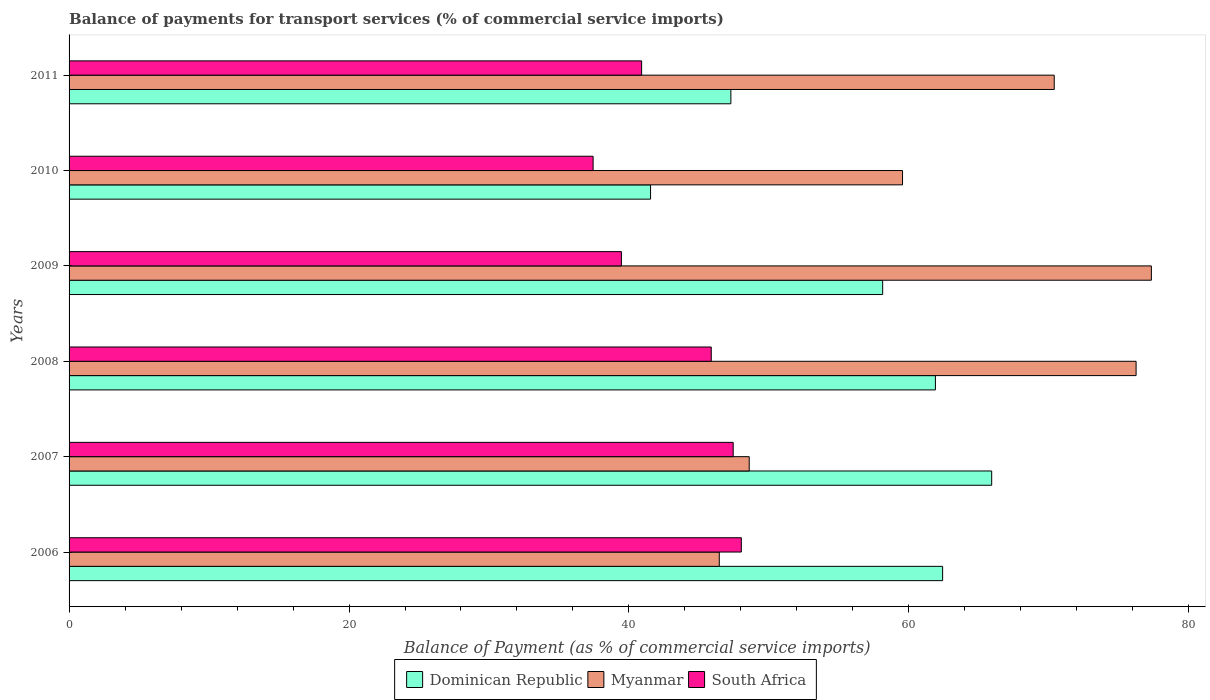How many different coloured bars are there?
Your answer should be compact. 3. How many groups of bars are there?
Provide a succinct answer. 6. Are the number of bars per tick equal to the number of legend labels?
Make the answer very short. Yes. Are the number of bars on each tick of the Y-axis equal?
Give a very brief answer. Yes. How many bars are there on the 2nd tick from the top?
Ensure brevity in your answer.  3. How many bars are there on the 6th tick from the bottom?
Give a very brief answer. 3. What is the label of the 3rd group of bars from the top?
Your answer should be compact. 2009. In how many cases, is the number of bars for a given year not equal to the number of legend labels?
Your answer should be compact. 0. What is the balance of payments for transport services in South Africa in 2008?
Provide a short and direct response. 45.88. Across all years, what is the maximum balance of payments for transport services in Dominican Republic?
Your answer should be very brief. 65.92. Across all years, what is the minimum balance of payments for transport services in Myanmar?
Offer a terse response. 46.45. In which year was the balance of payments for transport services in Myanmar maximum?
Offer a terse response. 2009. What is the total balance of payments for transport services in South Africa in the graph?
Give a very brief answer. 259.16. What is the difference between the balance of payments for transport services in Dominican Republic in 2008 and that in 2009?
Keep it short and to the point. 3.77. What is the difference between the balance of payments for transport services in Dominican Republic in 2011 and the balance of payments for transport services in South Africa in 2008?
Your answer should be very brief. 1.4. What is the average balance of payments for transport services in Myanmar per year?
Your answer should be compact. 63.09. In the year 2007, what is the difference between the balance of payments for transport services in Dominican Republic and balance of payments for transport services in Myanmar?
Ensure brevity in your answer.  17.32. What is the ratio of the balance of payments for transport services in South Africa in 2006 to that in 2011?
Your answer should be very brief. 1.17. Is the balance of payments for transport services in Myanmar in 2006 less than that in 2011?
Your answer should be very brief. Yes. What is the difference between the highest and the second highest balance of payments for transport services in Dominican Republic?
Provide a short and direct response. 3.5. What is the difference between the highest and the lowest balance of payments for transport services in Dominican Republic?
Offer a terse response. 24.37. In how many years, is the balance of payments for transport services in Dominican Republic greater than the average balance of payments for transport services in Dominican Republic taken over all years?
Your answer should be compact. 4. What does the 3rd bar from the top in 2006 represents?
Your answer should be compact. Dominican Republic. What does the 2nd bar from the bottom in 2009 represents?
Offer a terse response. Myanmar. Are all the bars in the graph horizontal?
Provide a succinct answer. Yes. How many years are there in the graph?
Offer a very short reply. 6. What is the difference between two consecutive major ticks on the X-axis?
Provide a succinct answer. 20. Are the values on the major ticks of X-axis written in scientific E-notation?
Your answer should be compact. No. Does the graph contain grids?
Keep it short and to the point. No. Where does the legend appear in the graph?
Your response must be concise. Bottom center. How are the legend labels stacked?
Provide a succinct answer. Horizontal. What is the title of the graph?
Give a very brief answer. Balance of payments for transport services (% of commercial service imports). Does "Canada" appear as one of the legend labels in the graph?
Give a very brief answer. No. What is the label or title of the X-axis?
Provide a short and direct response. Balance of Payment (as % of commercial service imports). What is the Balance of Payment (as % of commercial service imports) of Dominican Republic in 2006?
Offer a terse response. 62.41. What is the Balance of Payment (as % of commercial service imports) in Myanmar in 2006?
Your answer should be very brief. 46.45. What is the Balance of Payment (as % of commercial service imports) of South Africa in 2006?
Make the answer very short. 48.03. What is the Balance of Payment (as % of commercial service imports) of Dominican Republic in 2007?
Provide a short and direct response. 65.92. What is the Balance of Payment (as % of commercial service imports) of Myanmar in 2007?
Make the answer very short. 48.59. What is the Balance of Payment (as % of commercial service imports) of South Africa in 2007?
Ensure brevity in your answer.  47.45. What is the Balance of Payment (as % of commercial service imports) of Dominican Republic in 2008?
Offer a very short reply. 61.9. What is the Balance of Payment (as % of commercial service imports) in Myanmar in 2008?
Ensure brevity in your answer.  76.23. What is the Balance of Payment (as % of commercial service imports) in South Africa in 2008?
Provide a short and direct response. 45.88. What is the Balance of Payment (as % of commercial service imports) in Dominican Republic in 2009?
Make the answer very short. 58.13. What is the Balance of Payment (as % of commercial service imports) in Myanmar in 2009?
Give a very brief answer. 77.32. What is the Balance of Payment (as % of commercial service imports) in South Africa in 2009?
Ensure brevity in your answer.  39.46. What is the Balance of Payment (as % of commercial service imports) in Dominican Republic in 2010?
Ensure brevity in your answer.  41.54. What is the Balance of Payment (as % of commercial service imports) of Myanmar in 2010?
Ensure brevity in your answer.  59.55. What is the Balance of Payment (as % of commercial service imports) in South Africa in 2010?
Give a very brief answer. 37.44. What is the Balance of Payment (as % of commercial service imports) in Dominican Republic in 2011?
Give a very brief answer. 47.28. What is the Balance of Payment (as % of commercial service imports) in Myanmar in 2011?
Provide a short and direct response. 70.38. What is the Balance of Payment (as % of commercial service imports) in South Africa in 2011?
Your answer should be very brief. 40.91. Across all years, what is the maximum Balance of Payment (as % of commercial service imports) of Dominican Republic?
Offer a very short reply. 65.92. Across all years, what is the maximum Balance of Payment (as % of commercial service imports) in Myanmar?
Your response must be concise. 77.32. Across all years, what is the maximum Balance of Payment (as % of commercial service imports) in South Africa?
Provide a succinct answer. 48.03. Across all years, what is the minimum Balance of Payment (as % of commercial service imports) in Dominican Republic?
Your answer should be compact. 41.54. Across all years, what is the minimum Balance of Payment (as % of commercial service imports) of Myanmar?
Keep it short and to the point. 46.45. Across all years, what is the minimum Balance of Payment (as % of commercial service imports) of South Africa?
Give a very brief answer. 37.44. What is the total Balance of Payment (as % of commercial service imports) in Dominican Republic in the graph?
Your answer should be compact. 337.18. What is the total Balance of Payment (as % of commercial service imports) of Myanmar in the graph?
Give a very brief answer. 378.54. What is the total Balance of Payment (as % of commercial service imports) in South Africa in the graph?
Your response must be concise. 259.16. What is the difference between the Balance of Payment (as % of commercial service imports) of Dominican Republic in 2006 and that in 2007?
Offer a terse response. -3.5. What is the difference between the Balance of Payment (as % of commercial service imports) in Myanmar in 2006 and that in 2007?
Offer a terse response. -2.14. What is the difference between the Balance of Payment (as % of commercial service imports) of South Africa in 2006 and that in 2007?
Offer a terse response. 0.58. What is the difference between the Balance of Payment (as % of commercial service imports) in Dominican Republic in 2006 and that in 2008?
Offer a terse response. 0.52. What is the difference between the Balance of Payment (as % of commercial service imports) in Myanmar in 2006 and that in 2008?
Make the answer very short. -29.78. What is the difference between the Balance of Payment (as % of commercial service imports) in South Africa in 2006 and that in 2008?
Ensure brevity in your answer.  2.15. What is the difference between the Balance of Payment (as % of commercial service imports) of Dominican Republic in 2006 and that in 2009?
Your answer should be compact. 4.28. What is the difference between the Balance of Payment (as % of commercial service imports) of Myanmar in 2006 and that in 2009?
Ensure brevity in your answer.  -30.87. What is the difference between the Balance of Payment (as % of commercial service imports) of South Africa in 2006 and that in 2009?
Your answer should be compact. 8.57. What is the difference between the Balance of Payment (as % of commercial service imports) of Dominican Republic in 2006 and that in 2010?
Your answer should be compact. 20.87. What is the difference between the Balance of Payment (as % of commercial service imports) of Myanmar in 2006 and that in 2010?
Make the answer very short. -13.09. What is the difference between the Balance of Payment (as % of commercial service imports) in South Africa in 2006 and that in 2010?
Give a very brief answer. 10.59. What is the difference between the Balance of Payment (as % of commercial service imports) in Dominican Republic in 2006 and that in 2011?
Offer a terse response. 15.13. What is the difference between the Balance of Payment (as % of commercial service imports) in Myanmar in 2006 and that in 2011?
Offer a very short reply. -23.93. What is the difference between the Balance of Payment (as % of commercial service imports) in South Africa in 2006 and that in 2011?
Provide a succinct answer. 7.12. What is the difference between the Balance of Payment (as % of commercial service imports) of Dominican Republic in 2007 and that in 2008?
Your answer should be compact. 4.02. What is the difference between the Balance of Payment (as % of commercial service imports) of Myanmar in 2007 and that in 2008?
Your answer should be very brief. -27.64. What is the difference between the Balance of Payment (as % of commercial service imports) of South Africa in 2007 and that in 2008?
Keep it short and to the point. 1.57. What is the difference between the Balance of Payment (as % of commercial service imports) of Dominican Republic in 2007 and that in 2009?
Offer a very short reply. 7.79. What is the difference between the Balance of Payment (as % of commercial service imports) of Myanmar in 2007 and that in 2009?
Provide a short and direct response. -28.73. What is the difference between the Balance of Payment (as % of commercial service imports) of South Africa in 2007 and that in 2009?
Keep it short and to the point. 7.99. What is the difference between the Balance of Payment (as % of commercial service imports) in Dominican Republic in 2007 and that in 2010?
Offer a very short reply. 24.37. What is the difference between the Balance of Payment (as % of commercial service imports) of Myanmar in 2007 and that in 2010?
Keep it short and to the point. -10.95. What is the difference between the Balance of Payment (as % of commercial service imports) in South Africa in 2007 and that in 2010?
Make the answer very short. 10.01. What is the difference between the Balance of Payment (as % of commercial service imports) of Dominican Republic in 2007 and that in 2011?
Give a very brief answer. 18.63. What is the difference between the Balance of Payment (as % of commercial service imports) of Myanmar in 2007 and that in 2011?
Your answer should be very brief. -21.79. What is the difference between the Balance of Payment (as % of commercial service imports) in South Africa in 2007 and that in 2011?
Your answer should be compact. 6.54. What is the difference between the Balance of Payment (as % of commercial service imports) in Dominican Republic in 2008 and that in 2009?
Offer a terse response. 3.77. What is the difference between the Balance of Payment (as % of commercial service imports) in Myanmar in 2008 and that in 2009?
Provide a short and direct response. -1.09. What is the difference between the Balance of Payment (as % of commercial service imports) in South Africa in 2008 and that in 2009?
Provide a succinct answer. 6.42. What is the difference between the Balance of Payment (as % of commercial service imports) in Dominican Republic in 2008 and that in 2010?
Ensure brevity in your answer.  20.35. What is the difference between the Balance of Payment (as % of commercial service imports) of Myanmar in 2008 and that in 2010?
Give a very brief answer. 16.69. What is the difference between the Balance of Payment (as % of commercial service imports) in South Africa in 2008 and that in 2010?
Offer a very short reply. 8.44. What is the difference between the Balance of Payment (as % of commercial service imports) of Dominican Republic in 2008 and that in 2011?
Provide a succinct answer. 14.61. What is the difference between the Balance of Payment (as % of commercial service imports) of Myanmar in 2008 and that in 2011?
Your answer should be very brief. 5.85. What is the difference between the Balance of Payment (as % of commercial service imports) of South Africa in 2008 and that in 2011?
Offer a terse response. 4.97. What is the difference between the Balance of Payment (as % of commercial service imports) of Dominican Republic in 2009 and that in 2010?
Your answer should be very brief. 16.58. What is the difference between the Balance of Payment (as % of commercial service imports) of Myanmar in 2009 and that in 2010?
Offer a very short reply. 17.78. What is the difference between the Balance of Payment (as % of commercial service imports) of South Africa in 2009 and that in 2010?
Make the answer very short. 2.02. What is the difference between the Balance of Payment (as % of commercial service imports) of Dominican Republic in 2009 and that in 2011?
Offer a terse response. 10.85. What is the difference between the Balance of Payment (as % of commercial service imports) in Myanmar in 2009 and that in 2011?
Make the answer very short. 6.94. What is the difference between the Balance of Payment (as % of commercial service imports) of South Africa in 2009 and that in 2011?
Offer a terse response. -1.44. What is the difference between the Balance of Payment (as % of commercial service imports) in Dominican Republic in 2010 and that in 2011?
Your answer should be very brief. -5.74. What is the difference between the Balance of Payment (as % of commercial service imports) in Myanmar in 2010 and that in 2011?
Give a very brief answer. -10.84. What is the difference between the Balance of Payment (as % of commercial service imports) in South Africa in 2010 and that in 2011?
Ensure brevity in your answer.  -3.47. What is the difference between the Balance of Payment (as % of commercial service imports) in Dominican Republic in 2006 and the Balance of Payment (as % of commercial service imports) in Myanmar in 2007?
Provide a short and direct response. 13.82. What is the difference between the Balance of Payment (as % of commercial service imports) of Dominican Republic in 2006 and the Balance of Payment (as % of commercial service imports) of South Africa in 2007?
Your answer should be very brief. 14.96. What is the difference between the Balance of Payment (as % of commercial service imports) of Myanmar in 2006 and the Balance of Payment (as % of commercial service imports) of South Africa in 2007?
Ensure brevity in your answer.  -0.99. What is the difference between the Balance of Payment (as % of commercial service imports) in Dominican Republic in 2006 and the Balance of Payment (as % of commercial service imports) in Myanmar in 2008?
Your answer should be compact. -13.82. What is the difference between the Balance of Payment (as % of commercial service imports) in Dominican Republic in 2006 and the Balance of Payment (as % of commercial service imports) in South Africa in 2008?
Ensure brevity in your answer.  16.53. What is the difference between the Balance of Payment (as % of commercial service imports) in Myanmar in 2006 and the Balance of Payment (as % of commercial service imports) in South Africa in 2008?
Your answer should be very brief. 0.57. What is the difference between the Balance of Payment (as % of commercial service imports) in Dominican Republic in 2006 and the Balance of Payment (as % of commercial service imports) in Myanmar in 2009?
Make the answer very short. -14.91. What is the difference between the Balance of Payment (as % of commercial service imports) of Dominican Republic in 2006 and the Balance of Payment (as % of commercial service imports) of South Africa in 2009?
Make the answer very short. 22.95. What is the difference between the Balance of Payment (as % of commercial service imports) in Myanmar in 2006 and the Balance of Payment (as % of commercial service imports) in South Africa in 2009?
Provide a succinct answer. 6.99. What is the difference between the Balance of Payment (as % of commercial service imports) in Dominican Republic in 2006 and the Balance of Payment (as % of commercial service imports) in Myanmar in 2010?
Make the answer very short. 2.86. What is the difference between the Balance of Payment (as % of commercial service imports) in Dominican Republic in 2006 and the Balance of Payment (as % of commercial service imports) in South Africa in 2010?
Offer a terse response. 24.97. What is the difference between the Balance of Payment (as % of commercial service imports) in Myanmar in 2006 and the Balance of Payment (as % of commercial service imports) in South Africa in 2010?
Your answer should be compact. 9.01. What is the difference between the Balance of Payment (as % of commercial service imports) of Dominican Republic in 2006 and the Balance of Payment (as % of commercial service imports) of Myanmar in 2011?
Keep it short and to the point. -7.97. What is the difference between the Balance of Payment (as % of commercial service imports) in Dominican Republic in 2006 and the Balance of Payment (as % of commercial service imports) in South Africa in 2011?
Offer a terse response. 21.51. What is the difference between the Balance of Payment (as % of commercial service imports) in Myanmar in 2006 and the Balance of Payment (as % of commercial service imports) in South Africa in 2011?
Give a very brief answer. 5.55. What is the difference between the Balance of Payment (as % of commercial service imports) of Dominican Republic in 2007 and the Balance of Payment (as % of commercial service imports) of Myanmar in 2008?
Your answer should be very brief. -10.32. What is the difference between the Balance of Payment (as % of commercial service imports) of Dominican Republic in 2007 and the Balance of Payment (as % of commercial service imports) of South Africa in 2008?
Your response must be concise. 20.04. What is the difference between the Balance of Payment (as % of commercial service imports) of Myanmar in 2007 and the Balance of Payment (as % of commercial service imports) of South Africa in 2008?
Keep it short and to the point. 2.71. What is the difference between the Balance of Payment (as % of commercial service imports) of Dominican Republic in 2007 and the Balance of Payment (as % of commercial service imports) of Myanmar in 2009?
Your answer should be compact. -11.41. What is the difference between the Balance of Payment (as % of commercial service imports) in Dominican Republic in 2007 and the Balance of Payment (as % of commercial service imports) in South Africa in 2009?
Your answer should be compact. 26.45. What is the difference between the Balance of Payment (as % of commercial service imports) of Myanmar in 2007 and the Balance of Payment (as % of commercial service imports) of South Africa in 2009?
Give a very brief answer. 9.13. What is the difference between the Balance of Payment (as % of commercial service imports) of Dominican Republic in 2007 and the Balance of Payment (as % of commercial service imports) of Myanmar in 2010?
Make the answer very short. 6.37. What is the difference between the Balance of Payment (as % of commercial service imports) in Dominican Republic in 2007 and the Balance of Payment (as % of commercial service imports) in South Africa in 2010?
Your answer should be compact. 28.48. What is the difference between the Balance of Payment (as % of commercial service imports) in Myanmar in 2007 and the Balance of Payment (as % of commercial service imports) in South Africa in 2010?
Provide a short and direct response. 11.15. What is the difference between the Balance of Payment (as % of commercial service imports) of Dominican Republic in 2007 and the Balance of Payment (as % of commercial service imports) of Myanmar in 2011?
Your answer should be compact. -4.47. What is the difference between the Balance of Payment (as % of commercial service imports) of Dominican Republic in 2007 and the Balance of Payment (as % of commercial service imports) of South Africa in 2011?
Provide a succinct answer. 25.01. What is the difference between the Balance of Payment (as % of commercial service imports) in Myanmar in 2007 and the Balance of Payment (as % of commercial service imports) in South Africa in 2011?
Offer a terse response. 7.69. What is the difference between the Balance of Payment (as % of commercial service imports) of Dominican Republic in 2008 and the Balance of Payment (as % of commercial service imports) of Myanmar in 2009?
Offer a very short reply. -15.43. What is the difference between the Balance of Payment (as % of commercial service imports) of Dominican Republic in 2008 and the Balance of Payment (as % of commercial service imports) of South Africa in 2009?
Offer a very short reply. 22.43. What is the difference between the Balance of Payment (as % of commercial service imports) of Myanmar in 2008 and the Balance of Payment (as % of commercial service imports) of South Africa in 2009?
Provide a short and direct response. 36.77. What is the difference between the Balance of Payment (as % of commercial service imports) in Dominican Republic in 2008 and the Balance of Payment (as % of commercial service imports) in Myanmar in 2010?
Ensure brevity in your answer.  2.35. What is the difference between the Balance of Payment (as % of commercial service imports) in Dominican Republic in 2008 and the Balance of Payment (as % of commercial service imports) in South Africa in 2010?
Offer a terse response. 24.46. What is the difference between the Balance of Payment (as % of commercial service imports) in Myanmar in 2008 and the Balance of Payment (as % of commercial service imports) in South Africa in 2010?
Make the answer very short. 38.79. What is the difference between the Balance of Payment (as % of commercial service imports) in Dominican Republic in 2008 and the Balance of Payment (as % of commercial service imports) in Myanmar in 2011?
Give a very brief answer. -8.49. What is the difference between the Balance of Payment (as % of commercial service imports) of Dominican Republic in 2008 and the Balance of Payment (as % of commercial service imports) of South Africa in 2011?
Your answer should be very brief. 20.99. What is the difference between the Balance of Payment (as % of commercial service imports) in Myanmar in 2008 and the Balance of Payment (as % of commercial service imports) in South Africa in 2011?
Offer a terse response. 35.33. What is the difference between the Balance of Payment (as % of commercial service imports) in Dominican Republic in 2009 and the Balance of Payment (as % of commercial service imports) in Myanmar in 2010?
Offer a very short reply. -1.42. What is the difference between the Balance of Payment (as % of commercial service imports) in Dominican Republic in 2009 and the Balance of Payment (as % of commercial service imports) in South Africa in 2010?
Offer a terse response. 20.69. What is the difference between the Balance of Payment (as % of commercial service imports) of Myanmar in 2009 and the Balance of Payment (as % of commercial service imports) of South Africa in 2010?
Your response must be concise. 39.88. What is the difference between the Balance of Payment (as % of commercial service imports) in Dominican Republic in 2009 and the Balance of Payment (as % of commercial service imports) in Myanmar in 2011?
Ensure brevity in your answer.  -12.26. What is the difference between the Balance of Payment (as % of commercial service imports) of Dominican Republic in 2009 and the Balance of Payment (as % of commercial service imports) of South Africa in 2011?
Provide a short and direct response. 17.22. What is the difference between the Balance of Payment (as % of commercial service imports) of Myanmar in 2009 and the Balance of Payment (as % of commercial service imports) of South Africa in 2011?
Your answer should be very brief. 36.42. What is the difference between the Balance of Payment (as % of commercial service imports) of Dominican Republic in 2010 and the Balance of Payment (as % of commercial service imports) of Myanmar in 2011?
Provide a short and direct response. -28.84. What is the difference between the Balance of Payment (as % of commercial service imports) of Dominican Republic in 2010 and the Balance of Payment (as % of commercial service imports) of South Africa in 2011?
Offer a terse response. 0.64. What is the difference between the Balance of Payment (as % of commercial service imports) in Myanmar in 2010 and the Balance of Payment (as % of commercial service imports) in South Africa in 2011?
Make the answer very short. 18.64. What is the average Balance of Payment (as % of commercial service imports) in Dominican Republic per year?
Give a very brief answer. 56.2. What is the average Balance of Payment (as % of commercial service imports) of Myanmar per year?
Offer a terse response. 63.09. What is the average Balance of Payment (as % of commercial service imports) in South Africa per year?
Offer a very short reply. 43.19. In the year 2006, what is the difference between the Balance of Payment (as % of commercial service imports) in Dominican Republic and Balance of Payment (as % of commercial service imports) in Myanmar?
Give a very brief answer. 15.96. In the year 2006, what is the difference between the Balance of Payment (as % of commercial service imports) of Dominican Republic and Balance of Payment (as % of commercial service imports) of South Africa?
Your response must be concise. 14.38. In the year 2006, what is the difference between the Balance of Payment (as % of commercial service imports) of Myanmar and Balance of Payment (as % of commercial service imports) of South Africa?
Make the answer very short. -1.58. In the year 2007, what is the difference between the Balance of Payment (as % of commercial service imports) in Dominican Republic and Balance of Payment (as % of commercial service imports) in Myanmar?
Make the answer very short. 17.32. In the year 2007, what is the difference between the Balance of Payment (as % of commercial service imports) of Dominican Republic and Balance of Payment (as % of commercial service imports) of South Africa?
Offer a terse response. 18.47. In the year 2007, what is the difference between the Balance of Payment (as % of commercial service imports) of Myanmar and Balance of Payment (as % of commercial service imports) of South Africa?
Provide a short and direct response. 1.14. In the year 2008, what is the difference between the Balance of Payment (as % of commercial service imports) of Dominican Republic and Balance of Payment (as % of commercial service imports) of Myanmar?
Ensure brevity in your answer.  -14.34. In the year 2008, what is the difference between the Balance of Payment (as % of commercial service imports) of Dominican Republic and Balance of Payment (as % of commercial service imports) of South Africa?
Keep it short and to the point. 16.02. In the year 2008, what is the difference between the Balance of Payment (as % of commercial service imports) in Myanmar and Balance of Payment (as % of commercial service imports) in South Africa?
Your answer should be very brief. 30.35. In the year 2009, what is the difference between the Balance of Payment (as % of commercial service imports) of Dominican Republic and Balance of Payment (as % of commercial service imports) of Myanmar?
Provide a short and direct response. -19.2. In the year 2009, what is the difference between the Balance of Payment (as % of commercial service imports) in Dominican Republic and Balance of Payment (as % of commercial service imports) in South Africa?
Give a very brief answer. 18.67. In the year 2009, what is the difference between the Balance of Payment (as % of commercial service imports) in Myanmar and Balance of Payment (as % of commercial service imports) in South Africa?
Give a very brief answer. 37.86. In the year 2010, what is the difference between the Balance of Payment (as % of commercial service imports) in Dominican Republic and Balance of Payment (as % of commercial service imports) in Myanmar?
Offer a terse response. -18. In the year 2010, what is the difference between the Balance of Payment (as % of commercial service imports) of Dominican Republic and Balance of Payment (as % of commercial service imports) of South Africa?
Your response must be concise. 4.1. In the year 2010, what is the difference between the Balance of Payment (as % of commercial service imports) in Myanmar and Balance of Payment (as % of commercial service imports) in South Africa?
Your answer should be compact. 22.11. In the year 2011, what is the difference between the Balance of Payment (as % of commercial service imports) in Dominican Republic and Balance of Payment (as % of commercial service imports) in Myanmar?
Keep it short and to the point. -23.1. In the year 2011, what is the difference between the Balance of Payment (as % of commercial service imports) in Dominican Republic and Balance of Payment (as % of commercial service imports) in South Africa?
Offer a very short reply. 6.38. In the year 2011, what is the difference between the Balance of Payment (as % of commercial service imports) of Myanmar and Balance of Payment (as % of commercial service imports) of South Africa?
Your answer should be very brief. 29.48. What is the ratio of the Balance of Payment (as % of commercial service imports) of Dominican Republic in 2006 to that in 2007?
Offer a terse response. 0.95. What is the ratio of the Balance of Payment (as % of commercial service imports) in Myanmar in 2006 to that in 2007?
Your response must be concise. 0.96. What is the ratio of the Balance of Payment (as % of commercial service imports) in South Africa in 2006 to that in 2007?
Provide a succinct answer. 1.01. What is the ratio of the Balance of Payment (as % of commercial service imports) of Dominican Republic in 2006 to that in 2008?
Make the answer very short. 1.01. What is the ratio of the Balance of Payment (as % of commercial service imports) of Myanmar in 2006 to that in 2008?
Offer a very short reply. 0.61. What is the ratio of the Balance of Payment (as % of commercial service imports) of South Africa in 2006 to that in 2008?
Offer a very short reply. 1.05. What is the ratio of the Balance of Payment (as % of commercial service imports) of Dominican Republic in 2006 to that in 2009?
Offer a very short reply. 1.07. What is the ratio of the Balance of Payment (as % of commercial service imports) in Myanmar in 2006 to that in 2009?
Give a very brief answer. 0.6. What is the ratio of the Balance of Payment (as % of commercial service imports) in South Africa in 2006 to that in 2009?
Give a very brief answer. 1.22. What is the ratio of the Balance of Payment (as % of commercial service imports) in Dominican Republic in 2006 to that in 2010?
Your answer should be compact. 1.5. What is the ratio of the Balance of Payment (as % of commercial service imports) of Myanmar in 2006 to that in 2010?
Your response must be concise. 0.78. What is the ratio of the Balance of Payment (as % of commercial service imports) in South Africa in 2006 to that in 2010?
Provide a succinct answer. 1.28. What is the ratio of the Balance of Payment (as % of commercial service imports) of Dominican Republic in 2006 to that in 2011?
Offer a terse response. 1.32. What is the ratio of the Balance of Payment (as % of commercial service imports) of Myanmar in 2006 to that in 2011?
Give a very brief answer. 0.66. What is the ratio of the Balance of Payment (as % of commercial service imports) in South Africa in 2006 to that in 2011?
Your answer should be compact. 1.17. What is the ratio of the Balance of Payment (as % of commercial service imports) in Dominican Republic in 2007 to that in 2008?
Make the answer very short. 1.06. What is the ratio of the Balance of Payment (as % of commercial service imports) in Myanmar in 2007 to that in 2008?
Keep it short and to the point. 0.64. What is the ratio of the Balance of Payment (as % of commercial service imports) in South Africa in 2007 to that in 2008?
Keep it short and to the point. 1.03. What is the ratio of the Balance of Payment (as % of commercial service imports) in Dominican Republic in 2007 to that in 2009?
Your answer should be very brief. 1.13. What is the ratio of the Balance of Payment (as % of commercial service imports) of Myanmar in 2007 to that in 2009?
Your answer should be compact. 0.63. What is the ratio of the Balance of Payment (as % of commercial service imports) in South Africa in 2007 to that in 2009?
Your answer should be compact. 1.2. What is the ratio of the Balance of Payment (as % of commercial service imports) in Dominican Republic in 2007 to that in 2010?
Keep it short and to the point. 1.59. What is the ratio of the Balance of Payment (as % of commercial service imports) in Myanmar in 2007 to that in 2010?
Your response must be concise. 0.82. What is the ratio of the Balance of Payment (as % of commercial service imports) of South Africa in 2007 to that in 2010?
Provide a succinct answer. 1.27. What is the ratio of the Balance of Payment (as % of commercial service imports) of Dominican Republic in 2007 to that in 2011?
Provide a succinct answer. 1.39. What is the ratio of the Balance of Payment (as % of commercial service imports) of Myanmar in 2007 to that in 2011?
Keep it short and to the point. 0.69. What is the ratio of the Balance of Payment (as % of commercial service imports) in South Africa in 2007 to that in 2011?
Give a very brief answer. 1.16. What is the ratio of the Balance of Payment (as % of commercial service imports) in Dominican Republic in 2008 to that in 2009?
Provide a succinct answer. 1.06. What is the ratio of the Balance of Payment (as % of commercial service imports) in Myanmar in 2008 to that in 2009?
Keep it short and to the point. 0.99. What is the ratio of the Balance of Payment (as % of commercial service imports) of South Africa in 2008 to that in 2009?
Make the answer very short. 1.16. What is the ratio of the Balance of Payment (as % of commercial service imports) of Dominican Republic in 2008 to that in 2010?
Offer a very short reply. 1.49. What is the ratio of the Balance of Payment (as % of commercial service imports) in Myanmar in 2008 to that in 2010?
Your answer should be compact. 1.28. What is the ratio of the Balance of Payment (as % of commercial service imports) in South Africa in 2008 to that in 2010?
Keep it short and to the point. 1.23. What is the ratio of the Balance of Payment (as % of commercial service imports) in Dominican Republic in 2008 to that in 2011?
Provide a short and direct response. 1.31. What is the ratio of the Balance of Payment (as % of commercial service imports) of Myanmar in 2008 to that in 2011?
Your response must be concise. 1.08. What is the ratio of the Balance of Payment (as % of commercial service imports) of South Africa in 2008 to that in 2011?
Offer a very short reply. 1.12. What is the ratio of the Balance of Payment (as % of commercial service imports) in Dominican Republic in 2009 to that in 2010?
Offer a terse response. 1.4. What is the ratio of the Balance of Payment (as % of commercial service imports) of Myanmar in 2009 to that in 2010?
Offer a terse response. 1.3. What is the ratio of the Balance of Payment (as % of commercial service imports) of South Africa in 2009 to that in 2010?
Offer a terse response. 1.05. What is the ratio of the Balance of Payment (as % of commercial service imports) in Dominican Republic in 2009 to that in 2011?
Make the answer very short. 1.23. What is the ratio of the Balance of Payment (as % of commercial service imports) in Myanmar in 2009 to that in 2011?
Provide a succinct answer. 1.1. What is the ratio of the Balance of Payment (as % of commercial service imports) of South Africa in 2009 to that in 2011?
Your answer should be very brief. 0.96. What is the ratio of the Balance of Payment (as % of commercial service imports) in Dominican Republic in 2010 to that in 2011?
Your response must be concise. 0.88. What is the ratio of the Balance of Payment (as % of commercial service imports) of Myanmar in 2010 to that in 2011?
Provide a succinct answer. 0.85. What is the ratio of the Balance of Payment (as % of commercial service imports) of South Africa in 2010 to that in 2011?
Provide a short and direct response. 0.92. What is the difference between the highest and the second highest Balance of Payment (as % of commercial service imports) in Dominican Republic?
Offer a terse response. 3.5. What is the difference between the highest and the second highest Balance of Payment (as % of commercial service imports) in Myanmar?
Ensure brevity in your answer.  1.09. What is the difference between the highest and the second highest Balance of Payment (as % of commercial service imports) of South Africa?
Give a very brief answer. 0.58. What is the difference between the highest and the lowest Balance of Payment (as % of commercial service imports) in Dominican Republic?
Provide a short and direct response. 24.37. What is the difference between the highest and the lowest Balance of Payment (as % of commercial service imports) of Myanmar?
Give a very brief answer. 30.87. What is the difference between the highest and the lowest Balance of Payment (as % of commercial service imports) in South Africa?
Provide a succinct answer. 10.59. 